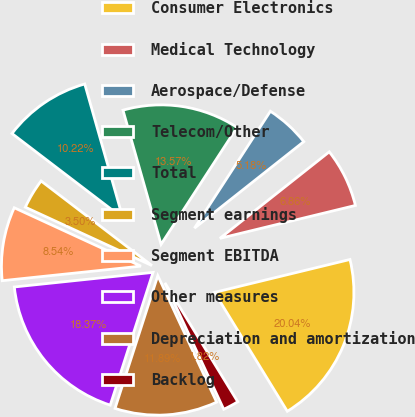Convert chart. <chart><loc_0><loc_0><loc_500><loc_500><pie_chart><fcel>Consumer Electronics<fcel>Medical Technology<fcel>Aerospace/Defense<fcel>Telecom/Other<fcel>Total<fcel>Segment earnings<fcel>Segment EBITDA<fcel>Other measures<fcel>Depreciation and amortization<fcel>Backlog<nl><fcel>20.04%<fcel>6.86%<fcel>5.18%<fcel>13.57%<fcel>10.22%<fcel>3.5%<fcel>8.54%<fcel>18.37%<fcel>11.89%<fcel>1.82%<nl></chart> 